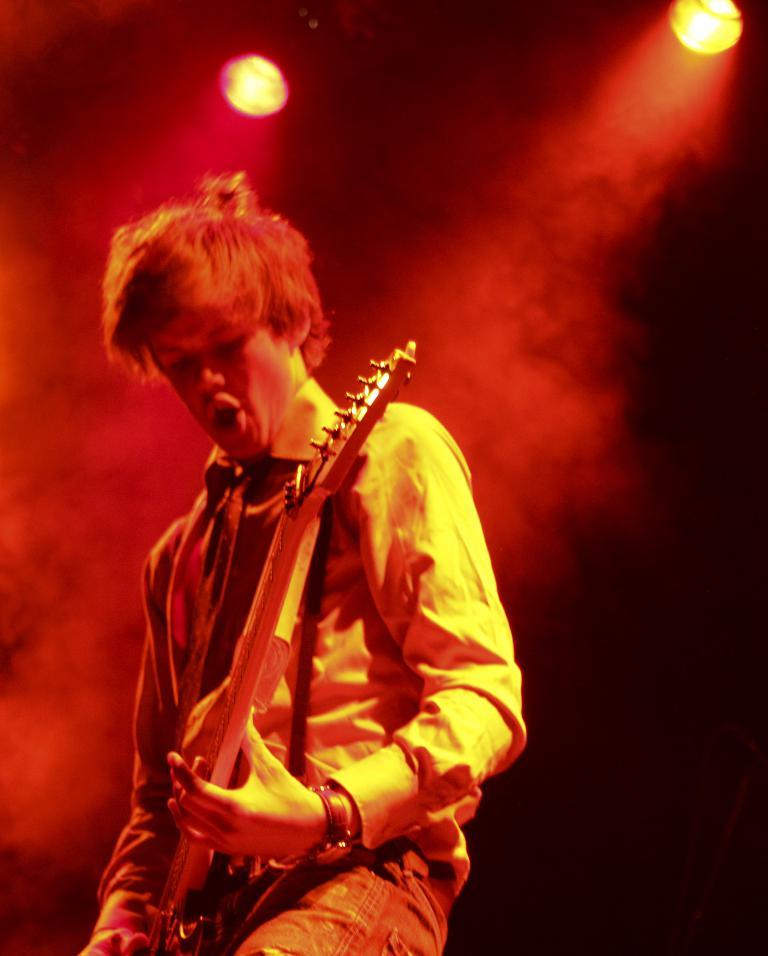What is the main subject of the image? There is a man standing in the image. What is the man wearing? The man is wearing clothes and a wrist watch. What object can be seen near the man? There is a guitar in the image. What can be observed in the background of the image? There is smoke and lights in the image. What type of rice can be seen cooking in the image? There is no rice present in the image. Can you describe the cart that is visible in the image? There is no cart present in the image. 